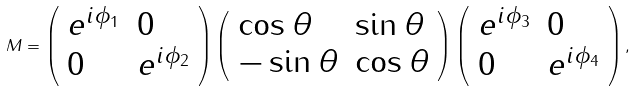Convert formula to latex. <formula><loc_0><loc_0><loc_500><loc_500>M = \left ( \begin{array} { l l } e ^ { i \phi _ { 1 } } & 0 \\ 0 & e ^ { i \phi _ { 2 } } \end{array} \right ) \left ( \begin{array} { l l } \cos \theta & \sin \theta \\ - \sin \theta & \cos \theta \end{array} \right ) \left ( \begin{array} { l l } e ^ { i \phi _ { 3 } } & 0 \\ 0 & e ^ { i \phi _ { 4 } } \end{array} \right ) ,</formula> 